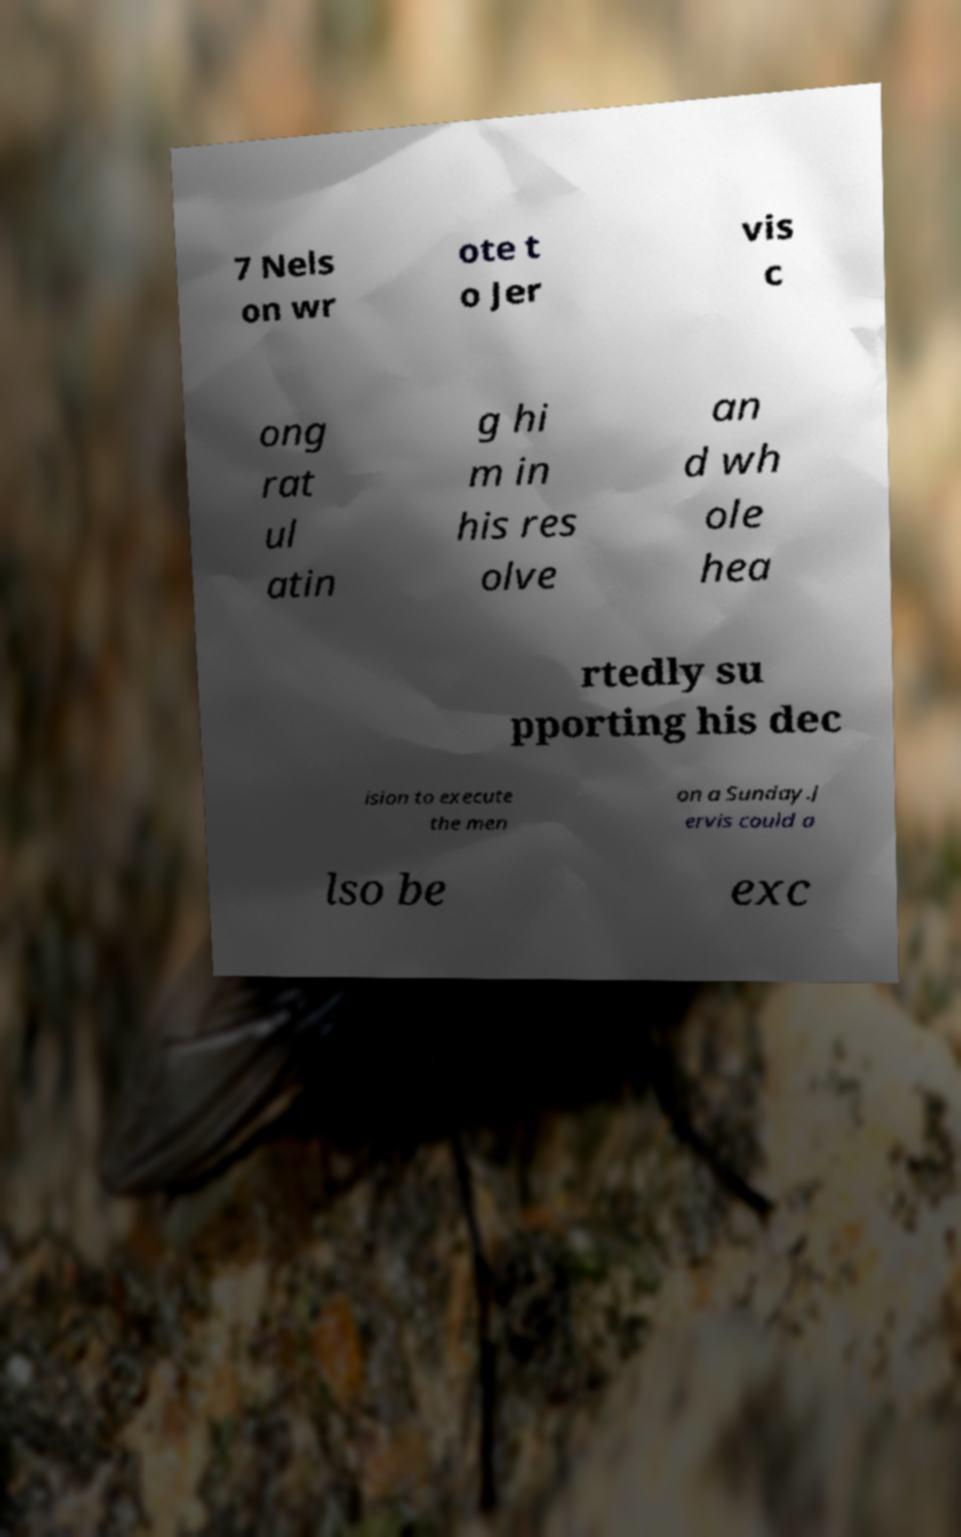What messages or text are displayed in this image? I need them in a readable, typed format. 7 Nels on wr ote t o Jer vis c ong rat ul atin g hi m in his res olve an d wh ole hea rtedly su pporting his dec ision to execute the men on a Sunday.J ervis could a lso be exc 